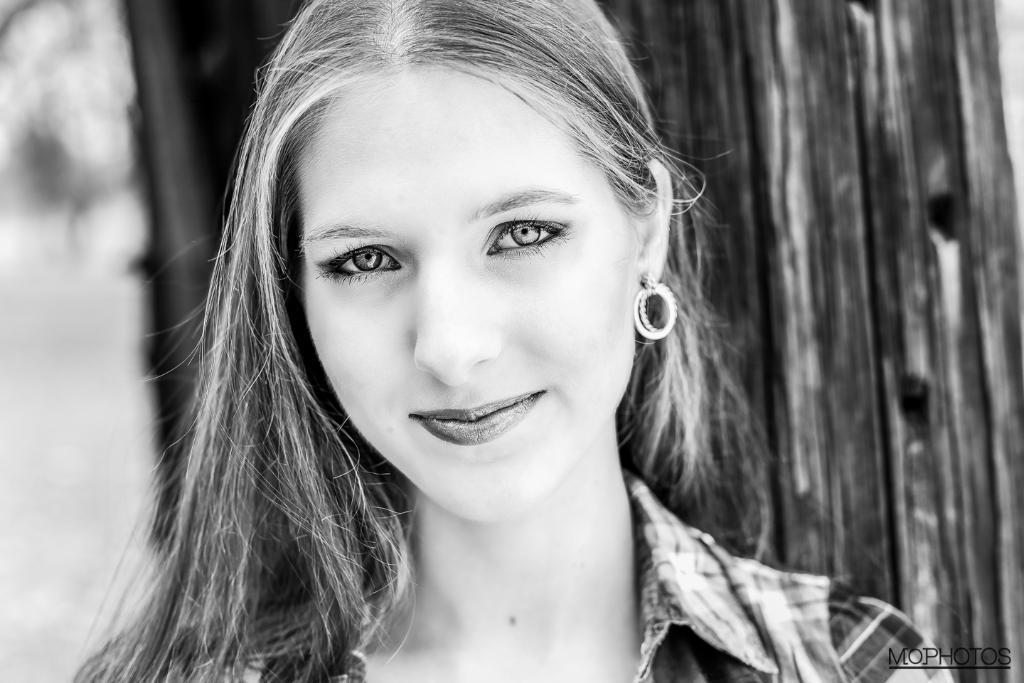Could you give a brief overview of what you see in this image? In this picture we can see a woman is smiling in the front, there is a blurry background, it is a black and white image. 